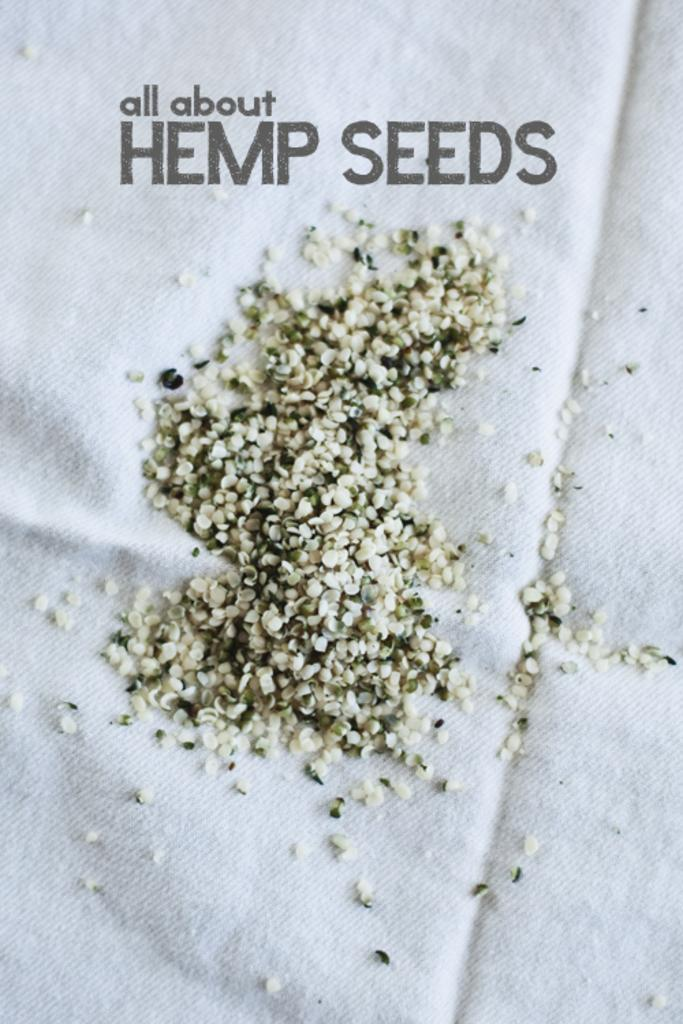What is the color of the cloth in the image? The cloth is white in color. What is on the cloth besides the cloth itself? There is text and seeds on the cloth. How many sisters are sitting on the cloth in the image? There are no sisters present in the image; it only features a cloth with text and seeds on it. 